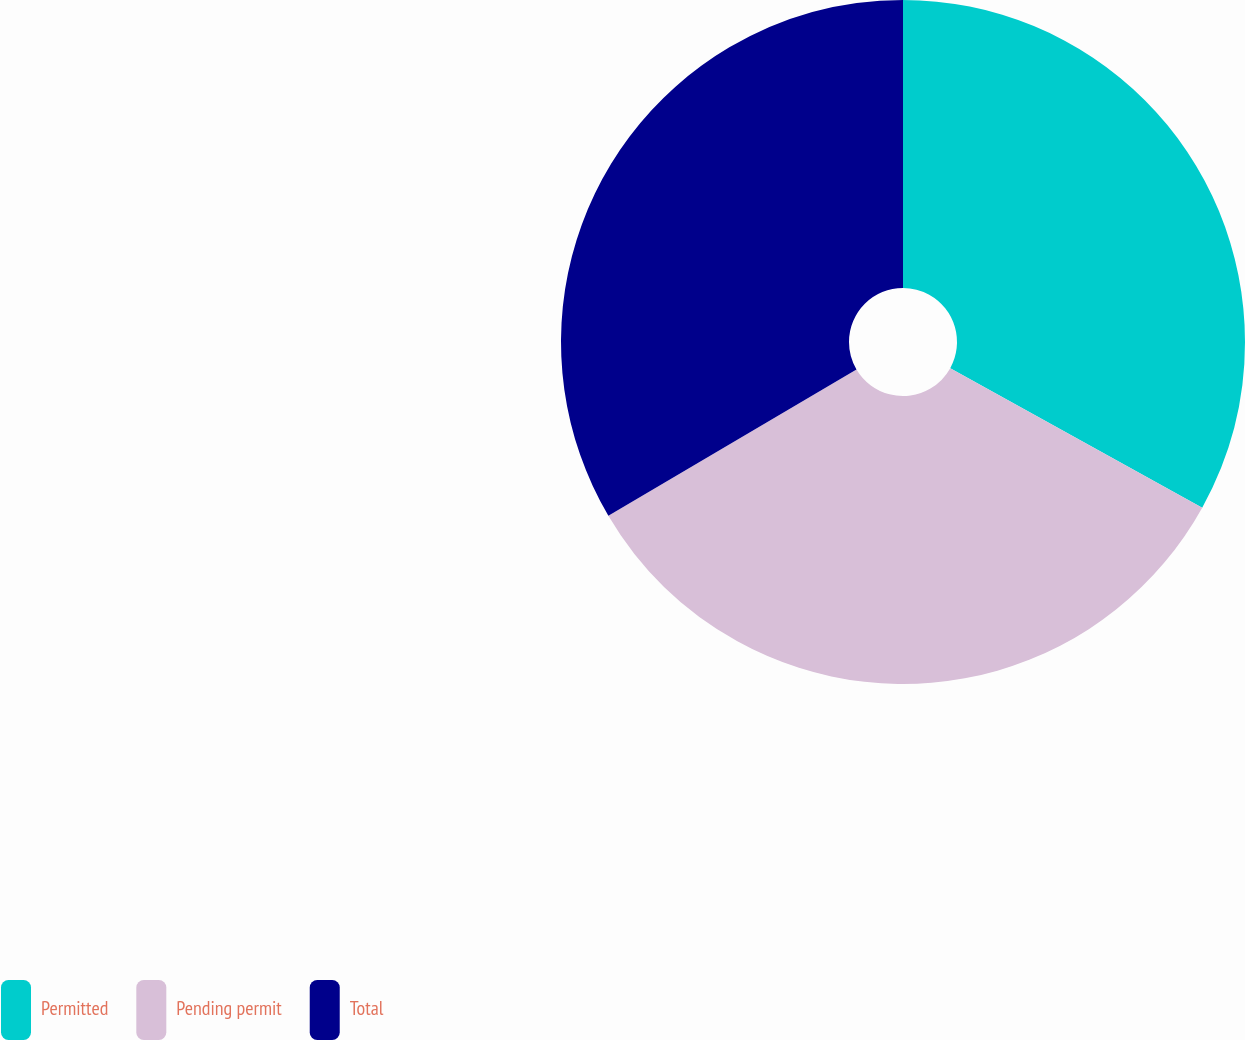Convert chart to OTSL. <chart><loc_0><loc_0><loc_500><loc_500><pie_chart><fcel>Permitted<fcel>Pending permit<fcel>Total<nl><fcel>33.05%<fcel>33.48%<fcel>33.48%<nl></chart> 